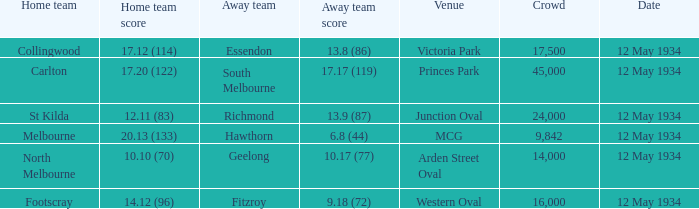Which home team played the Away team from Richmond? St Kilda. 